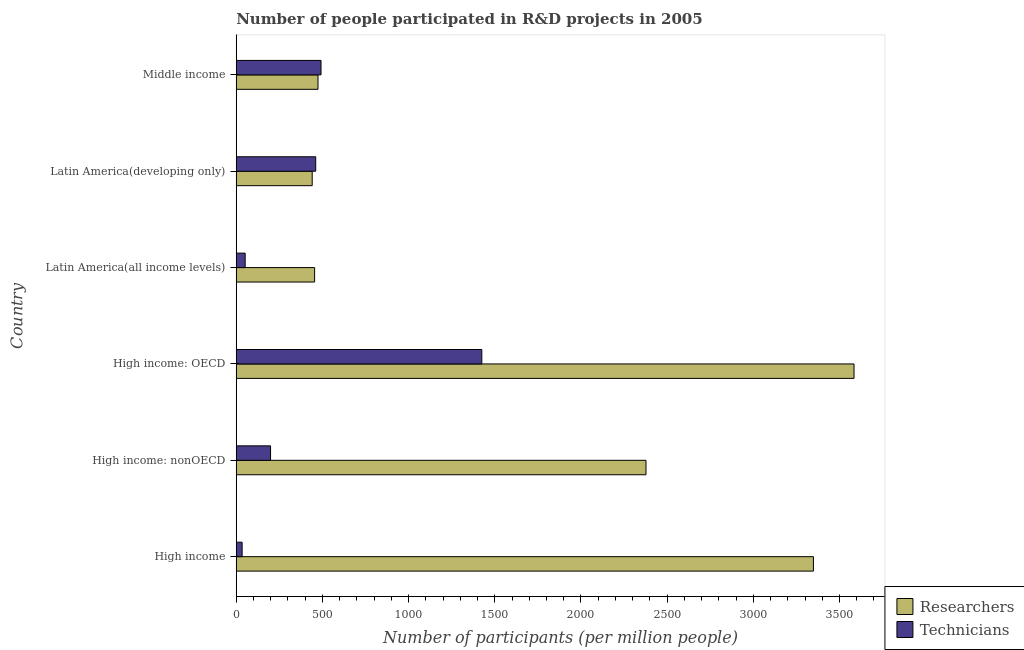How many different coloured bars are there?
Give a very brief answer. 2. How many groups of bars are there?
Offer a terse response. 6. Are the number of bars per tick equal to the number of legend labels?
Provide a succinct answer. Yes. Are the number of bars on each tick of the Y-axis equal?
Keep it short and to the point. Yes. How many bars are there on the 4th tick from the bottom?
Your response must be concise. 2. What is the label of the 2nd group of bars from the top?
Ensure brevity in your answer.  Latin America(developing only). In how many cases, is the number of bars for a given country not equal to the number of legend labels?
Ensure brevity in your answer.  0. What is the number of technicians in Latin America(all income levels)?
Provide a succinct answer. 51.7. Across all countries, what is the maximum number of researchers?
Offer a very short reply. 3584.25. Across all countries, what is the minimum number of technicians?
Give a very brief answer. 34.09. In which country was the number of technicians maximum?
Your answer should be very brief. High income: OECD. In which country was the number of researchers minimum?
Your response must be concise. Latin America(developing only). What is the total number of researchers in the graph?
Keep it short and to the point. 1.07e+04. What is the difference between the number of technicians in High income and that in High income: nonOECD?
Give a very brief answer. -164.86. What is the difference between the number of technicians in High income: OECD and the number of researchers in High income: nonOECD?
Provide a short and direct response. -952.62. What is the average number of researchers per country?
Ensure brevity in your answer.  1779.96. What is the difference between the number of technicians and number of researchers in High income: nonOECD?
Keep it short and to the point. -2178.35. In how many countries, is the number of technicians greater than 2500 ?
Keep it short and to the point. 0. What is the ratio of the number of technicians in High income: OECD to that in Latin America(all income levels)?
Ensure brevity in your answer.  27.56. What is the difference between the highest and the second highest number of researchers?
Make the answer very short. 235.59. What is the difference between the highest and the lowest number of technicians?
Give a very brief answer. 1390.59. What does the 1st bar from the top in High income: nonOECD represents?
Offer a very short reply. Technicians. What does the 2nd bar from the bottom in Latin America(all income levels) represents?
Your response must be concise. Technicians. What is the difference between two consecutive major ticks on the X-axis?
Give a very brief answer. 500. Are the values on the major ticks of X-axis written in scientific E-notation?
Ensure brevity in your answer.  No. Where does the legend appear in the graph?
Your answer should be compact. Bottom right. How many legend labels are there?
Offer a very short reply. 2. How are the legend labels stacked?
Your answer should be very brief. Vertical. What is the title of the graph?
Offer a very short reply. Number of people participated in R&D projects in 2005. What is the label or title of the X-axis?
Provide a short and direct response. Number of participants (per million people). What is the Number of participants (per million people) in Researchers in High income?
Offer a very short reply. 3348.65. What is the Number of participants (per million people) in Technicians in High income?
Ensure brevity in your answer.  34.09. What is the Number of participants (per million people) of Researchers in High income: nonOECD?
Your answer should be compact. 2377.3. What is the Number of participants (per million people) in Technicians in High income: nonOECD?
Make the answer very short. 198.95. What is the Number of participants (per million people) of Researchers in High income: OECD?
Make the answer very short. 3584.25. What is the Number of participants (per million people) of Technicians in High income: OECD?
Give a very brief answer. 1424.67. What is the Number of participants (per million people) in Researchers in Latin America(all income levels)?
Offer a very short reply. 454.61. What is the Number of participants (per million people) in Technicians in Latin America(all income levels)?
Provide a short and direct response. 51.7. What is the Number of participants (per million people) of Researchers in Latin America(developing only)?
Your answer should be compact. 440.62. What is the Number of participants (per million people) in Technicians in Latin America(developing only)?
Give a very brief answer. 460.92. What is the Number of participants (per million people) in Researchers in Middle income?
Your answer should be very brief. 474.32. What is the Number of participants (per million people) of Technicians in Middle income?
Ensure brevity in your answer.  491.76. Across all countries, what is the maximum Number of participants (per million people) of Researchers?
Your response must be concise. 3584.25. Across all countries, what is the maximum Number of participants (per million people) of Technicians?
Your answer should be very brief. 1424.67. Across all countries, what is the minimum Number of participants (per million people) in Researchers?
Provide a short and direct response. 440.62. Across all countries, what is the minimum Number of participants (per million people) of Technicians?
Ensure brevity in your answer.  34.09. What is the total Number of participants (per million people) of Researchers in the graph?
Ensure brevity in your answer.  1.07e+04. What is the total Number of participants (per million people) in Technicians in the graph?
Provide a short and direct response. 2662.08. What is the difference between the Number of participants (per million people) in Researchers in High income and that in High income: nonOECD?
Offer a terse response. 971.36. What is the difference between the Number of participants (per million people) in Technicians in High income and that in High income: nonOECD?
Provide a short and direct response. -164.86. What is the difference between the Number of participants (per million people) in Researchers in High income and that in High income: OECD?
Your answer should be very brief. -235.59. What is the difference between the Number of participants (per million people) of Technicians in High income and that in High income: OECD?
Give a very brief answer. -1390.59. What is the difference between the Number of participants (per million people) of Researchers in High income and that in Latin America(all income levels)?
Ensure brevity in your answer.  2894.04. What is the difference between the Number of participants (per million people) of Technicians in High income and that in Latin America(all income levels)?
Keep it short and to the point. -17.61. What is the difference between the Number of participants (per million people) in Researchers in High income and that in Latin America(developing only)?
Ensure brevity in your answer.  2908.04. What is the difference between the Number of participants (per million people) in Technicians in High income and that in Latin America(developing only)?
Give a very brief answer. -426.83. What is the difference between the Number of participants (per million people) of Researchers in High income and that in Middle income?
Provide a short and direct response. 2874.33. What is the difference between the Number of participants (per million people) of Technicians in High income and that in Middle income?
Keep it short and to the point. -457.67. What is the difference between the Number of participants (per million people) in Researchers in High income: nonOECD and that in High income: OECD?
Provide a short and direct response. -1206.95. What is the difference between the Number of participants (per million people) of Technicians in High income: nonOECD and that in High income: OECD?
Make the answer very short. -1225.72. What is the difference between the Number of participants (per million people) of Researchers in High income: nonOECD and that in Latin America(all income levels)?
Ensure brevity in your answer.  1922.69. What is the difference between the Number of participants (per million people) in Technicians in High income: nonOECD and that in Latin America(all income levels)?
Ensure brevity in your answer.  147.25. What is the difference between the Number of participants (per million people) in Researchers in High income: nonOECD and that in Latin America(developing only)?
Give a very brief answer. 1936.68. What is the difference between the Number of participants (per million people) of Technicians in High income: nonOECD and that in Latin America(developing only)?
Your answer should be compact. -261.97. What is the difference between the Number of participants (per million people) of Researchers in High income: nonOECD and that in Middle income?
Offer a very short reply. 1902.98. What is the difference between the Number of participants (per million people) of Technicians in High income: nonOECD and that in Middle income?
Provide a succinct answer. -292.81. What is the difference between the Number of participants (per million people) in Researchers in High income: OECD and that in Latin America(all income levels)?
Ensure brevity in your answer.  3129.64. What is the difference between the Number of participants (per million people) of Technicians in High income: OECD and that in Latin America(all income levels)?
Ensure brevity in your answer.  1372.98. What is the difference between the Number of participants (per million people) in Researchers in High income: OECD and that in Latin America(developing only)?
Provide a short and direct response. 3143.63. What is the difference between the Number of participants (per million people) of Technicians in High income: OECD and that in Latin America(developing only)?
Provide a short and direct response. 963.76. What is the difference between the Number of participants (per million people) of Researchers in High income: OECD and that in Middle income?
Your response must be concise. 3109.93. What is the difference between the Number of participants (per million people) in Technicians in High income: OECD and that in Middle income?
Your answer should be very brief. 932.91. What is the difference between the Number of participants (per million people) of Researchers in Latin America(all income levels) and that in Latin America(developing only)?
Ensure brevity in your answer.  13.99. What is the difference between the Number of participants (per million people) in Technicians in Latin America(all income levels) and that in Latin America(developing only)?
Your answer should be compact. -409.22. What is the difference between the Number of participants (per million people) of Researchers in Latin America(all income levels) and that in Middle income?
Your answer should be compact. -19.71. What is the difference between the Number of participants (per million people) in Technicians in Latin America(all income levels) and that in Middle income?
Offer a very short reply. -440.06. What is the difference between the Number of participants (per million people) of Researchers in Latin America(developing only) and that in Middle income?
Make the answer very short. -33.71. What is the difference between the Number of participants (per million people) of Technicians in Latin America(developing only) and that in Middle income?
Offer a very short reply. -30.84. What is the difference between the Number of participants (per million people) of Researchers in High income and the Number of participants (per million people) of Technicians in High income: nonOECD?
Provide a short and direct response. 3149.7. What is the difference between the Number of participants (per million people) in Researchers in High income and the Number of participants (per million people) in Technicians in High income: OECD?
Give a very brief answer. 1923.98. What is the difference between the Number of participants (per million people) of Researchers in High income and the Number of participants (per million people) of Technicians in Latin America(all income levels)?
Offer a terse response. 3296.96. What is the difference between the Number of participants (per million people) of Researchers in High income and the Number of participants (per million people) of Technicians in Latin America(developing only)?
Ensure brevity in your answer.  2887.74. What is the difference between the Number of participants (per million people) in Researchers in High income and the Number of participants (per million people) in Technicians in Middle income?
Keep it short and to the point. 2856.89. What is the difference between the Number of participants (per million people) in Researchers in High income: nonOECD and the Number of participants (per million people) in Technicians in High income: OECD?
Offer a terse response. 952.62. What is the difference between the Number of participants (per million people) in Researchers in High income: nonOECD and the Number of participants (per million people) in Technicians in Latin America(all income levels)?
Keep it short and to the point. 2325.6. What is the difference between the Number of participants (per million people) of Researchers in High income: nonOECD and the Number of participants (per million people) of Technicians in Latin America(developing only)?
Your answer should be compact. 1916.38. What is the difference between the Number of participants (per million people) in Researchers in High income: nonOECD and the Number of participants (per million people) in Technicians in Middle income?
Provide a short and direct response. 1885.54. What is the difference between the Number of participants (per million people) of Researchers in High income: OECD and the Number of participants (per million people) of Technicians in Latin America(all income levels)?
Your answer should be compact. 3532.55. What is the difference between the Number of participants (per million people) of Researchers in High income: OECD and the Number of participants (per million people) of Technicians in Latin America(developing only)?
Your answer should be very brief. 3123.33. What is the difference between the Number of participants (per million people) of Researchers in High income: OECD and the Number of participants (per million people) of Technicians in Middle income?
Ensure brevity in your answer.  3092.49. What is the difference between the Number of participants (per million people) of Researchers in Latin America(all income levels) and the Number of participants (per million people) of Technicians in Latin America(developing only)?
Keep it short and to the point. -6.31. What is the difference between the Number of participants (per million people) in Researchers in Latin America(all income levels) and the Number of participants (per million people) in Technicians in Middle income?
Your response must be concise. -37.15. What is the difference between the Number of participants (per million people) in Researchers in Latin America(developing only) and the Number of participants (per million people) in Technicians in Middle income?
Give a very brief answer. -51.14. What is the average Number of participants (per million people) of Researchers per country?
Ensure brevity in your answer.  1779.96. What is the average Number of participants (per million people) in Technicians per country?
Offer a very short reply. 443.68. What is the difference between the Number of participants (per million people) of Researchers and Number of participants (per million people) of Technicians in High income?
Your answer should be compact. 3314.57. What is the difference between the Number of participants (per million people) of Researchers and Number of participants (per million people) of Technicians in High income: nonOECD?
Your answer should be very brief. 2178.35. What is the difference between the Number of participants (per million people) of Researchers and Number of participants (per million people) of Technicians in High income: OECD?
Your answer should be very brief. 2159.57. What is the difference between the Number of participants (per million people) in Researchers and Number of participants (per million people) in Technicians in Latin America(all income levels)?
Provide a short and direct response. 402.91. What is the difference between the Number of participants (per million people) of Researchers and Number of participants (per million people) of Technicians in Latin America(developing only)?
Offer a terse response. -20.3. What is the difference between the Number of participants (per million people) in Researchers and Number of participants (per million people) in Technicians in Middle income?
Your answer should be very brief. -17.44. What is the ratio of the Number of participants (per million people) of Researchers in High income to that in High income: nonOECD?
Ensure brevity in your answer.  1.41. What is the ratio of the Number of participants (per million people) of Technicians in High income to that in High income: nonOECD?
Your answer should be compact. 0.17. What is the ratio of the Number of participants (per million people) in Researchers in High income to that in High income: OECD?
Make the answer very short. 0.93. What is the ratio of the Number of participants (per million people) of Technicians in High income to that in High income: OECD?
Ensure brevity in your answer.  0.02. What is the ratio of the Number of participants (per million people) in Researchers in High income to that in Latin America(all income levels)?
Provide a short and direct response. 7.37. What is the ratio of the Number of participants (per million people) of Technicians in High income to that in Latin America(all income levels)?
Provide a succinct answer. 0.66. What is the ratio of the Number of participants (per million people) in Researchers in High income to that in Latin America(developing only)?
Your answer should be very brief. 7.6. What is the ratio of the Number of participants (per million people) in Technicians in High income to that in Latin America(developing only)?
Provide a short and direct response. 0.07. What is the ratio of the Number of participants (per million people) of Researchers in High income to that in Middle income?
Your answer should be compact. 7.06. What is the ratio of the Number of participants (per million people) of Technicians in High income to that in Middle income?
Offer a very short reply. 0.07. What is the ratio of the Number of participants (per million people) in Researchers in High income: nonOECD to that in High income: OECD?
Keep it short and to the point. 0.66. What is the ratio of the Number of participants (per million people) in Technicians in High income: nonOECD to that in High income: OECD?
Provide a succinct answer. 0.14. What is the ratio of the Number of participants (per million people) in Researchers in High income: nonOECD to that in Latin America(all income levels)?
Your response must be concise. 5.23. What is the ratio of the Number of participants (per million people) of Technicians in High income: nonOECD to that in Latin America(all income levels)?
Provide a succinct answer. 3.85. What is the ratio of the Number of participants (per million people) of Researchers in High income: nonOECD to that in Latin America(developing only)?
Your answer should be compact. 5.4. What is the ratio of the Number of participants (per million people) in Technicians in High income: nonOECD to that in Latin America(developing only)?
Offer a very short reply. 0.43. What is the ratio of the Number of participants (per million people) of Researchers in High income: nonOECD to that in Middle income?
Your answer should be very brief. 5.01. What is the ratio of the Number of participants (per million people) in Technicians in High income: nonOECD to that in Middle income?
Make the answer very short. 0.4. What is the ratio of the Number of participants (per million people) in Researchers in High income: OECD to that in Latin America(all income levels)?
Provide a short and direct response. 7.88. What is the ratio of the Number of participants (per million people) of Technicians in High income: OECD to that in Latin America(all income levels)?
Ensure brevity in your answer.  27.56. What is the ratio of the Number of participants (per million people) in Researchers in High income: OECD to that in Latin America(developing only)?
Offer a very short reply. 8.13. What is the ratio of the Number of participants (per million people) in Technicians in High income: OECD to that in Latin America(developing only)?
Your response must be concise. 3.09. What is the ratio of the Number of participants (per million people) in Researchers in High income: OECD to that in Middle income?
Offer a terse response. 7.56. What is the ratio of the Number of participants (per million people) in Technicians in High income: OECD to that in Middle income?
Your answer should be very brief. 2.9. What is the ratio of the Number of participants (per million people) of Researchers in Latin America(all income levels) to that in Latin America(developing only)?
Offer a terse response. 1.03. What is the ratio of the Number of participants (per million people) in Technicians in Latin America(all income levels) to that in Latin America(developing only)?
Keep it short and to the point. 0.11. What is the ratio of the Number of participants (per million people) of Researchers in Latin America(all income levels) to that in Middle income?
Your answer should be compact. 0.96. What is the ratio of the Number of participants (per million people) of Technicians in Latin America(all income levels) to that in Middle income?
Provide a short and direct response. 0.11. What is the ratio of the Number of participants (per million people) of Researchers in Latin America(developing only) to that in Middle income?
Provide a succinct answer. 0.93. What is the ratio of the Number of participants (per million people) of Technicians in Latin America(developing only) to that in Middle income?
Your answer should be compact. 0.94. What is the difference between the highest and the second highest Number of participants (per million people) of Researchers?
Your answer should be very brief. 235.59. What is the difference between the highest and the second highest Number of participants (per million people) in Technicians?
Offer a terse response. 932.91. What is the difference between the highest and the lowest Number of participants (per million people) in Researchers?
Provide a succinct answer. 3143.63. What is the difference between the highest and the lowest Number of participants (per million people) of Technicians?
Make the answer very short. 1390.59. 